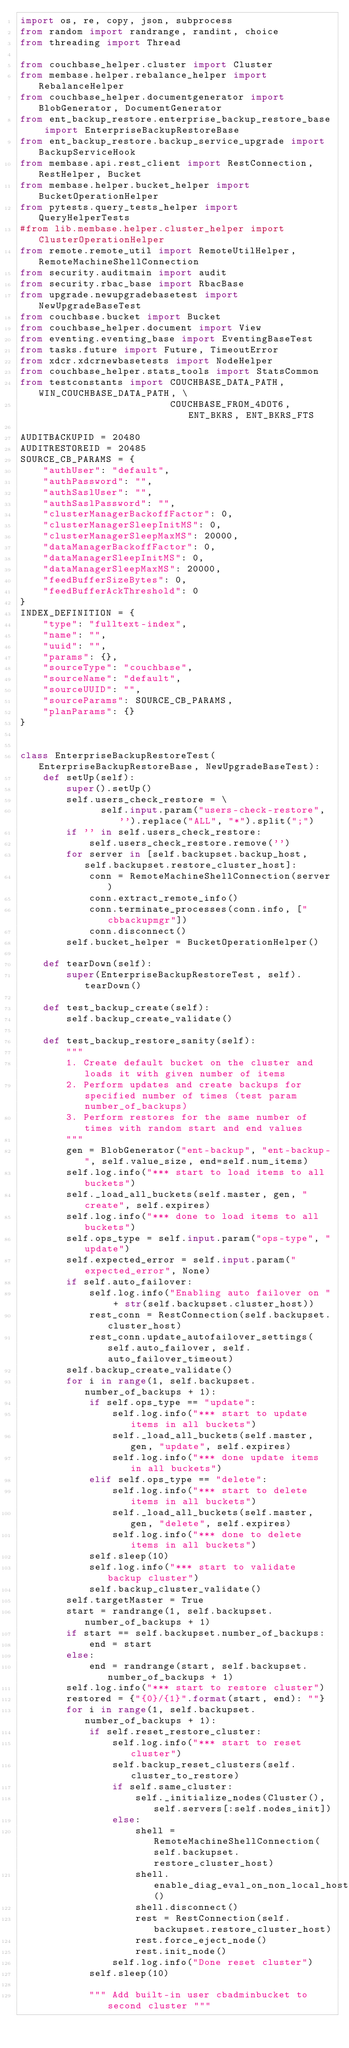Convert code to text. <code><loc_0><loc_0><loc_500><loc_500><_Python_>import os, re, copy, json, subprocess
from random import randrange, randint, choice
from threading import Thread

from couchbase_helper.cluster import Cluster
from membase.helper.rebalance_helper import RebalanceHelper
from couchbase_helper.documentgenerator import BlobGenerator, DocumentGenerator
from ent_backup_restore.enterprise_backup_restore_base import EnterpriseBackupRestoreBase
from ent_backup_restore.backup_service_upgrade import BackupServiceHook
from membase.api.rest_client import RestConnection, RestHelper, Bucket
from membase.helper.bucket_helper import BucketOperationHelper
from pytests.query_tests_helper import QueryHelperTests
#from lib.membase.helper.cluster_helper import ClusterOperationHelper
from remote.remote_util import RemoteUtilHelper, RemoteMachineShellConnection
from security.auditmain import audit
from security.rbac_base import RbacBase
from upgrade.newupgradebasetest import NewUpgradeBaseTest
from couchbase.bucket import Bucket
from couchbase_helper.document import View
from eventing.eventing_base import EventingBaseTest
from tasks.future import Future, TimeoutError
from xdcr.xdcrnewbasetests import NodeHelper
from couchbase_helper.stats_tools import StatsCommon
from testconstants import COUCHBASE_DATA_PATH, WIN_COUCHBASE_DATA_PATH, \
                          COUCHBASE_FROM_4DOT6, ENT_BKRS, ENT_BKRS_FTS

AUDITBACKUPID = 20480
AUDITRESTOREID = 20485
SOURCE_CB_PARAMS = {
    "authUser": "default",
    "authPassword": "",
    "authSaslUser": "",
    "authSaslPassword": "",
    "clusterManagerBackoffFactor": 0,
    "clusterManagerSleepInitMS": 0,
    "clusterManagerSleepMaxMS": 20000,
    "dataManagerBackoffFactor": 0,
    "dataManagerSleepInitMS": 0,
    "dataManagerSleepMaxMS": 20000,
    "feedBufferSizeBytes": 0,
    "feedBufferAckThreshold": 0
}
INDEX_DEFINITION = {
    "type": "fulltext-index",
    "name": "",
    "uuid": "",
    "params": {},
    "sourceType": "couchbase",
    "sourceName": "default",
    "sourceUUID": "",
    "sourceParams": SOURCE_CB_PARAMS,
    "planParams": {}
}


class EnterpriseBackupRestoreTest(EnterpriseBackupRestoreBase, NewUpgradeBaseTest):
    def setUp(self):
        super().setUp()
        self.users_check_restore = \
              self.input.param("users-check-restore", '').replace("ALL", "*").split(";")
        if '' in self.users_check_restore:
            self.users_check_restore.remove('')
        for server in [self.backupset.backup_host, self.backupset.restore_cluster_host]:
            conn = RemoteMachineShellConnection(server)
            conn.extract_remote_info()
            conn.terminate_processes(conn.info, ["cbbackupmgr"])
            conn.disconnect()
        self.bucket_helper = BucketOperationHelper()

    def tearDown(self):
        super(EnterpriseBackupRestoreTest, self).tearDown()

    def test_backup_create(self):
        self.backup_create_validate()

    def test_backup_restore_sanity(self):
        """
        1. Create default bucket on the cluster and loads it with given number of items
        2. Perform updates and create backups for specified number of times (test param number_of_backups)
        3. Perform restores for the same number of times with random start and end values
        """
        gen = BlobGenerator("ent-backup", "ent-backup-", self.value_size, end=self.num_items)
        self.log.info("*** start to load items to all buckets")
        self._load_all_buckets(self.master, gen, "create", self.expires)
        self.log.info("*** done to load items to all buckets")
        self.ops_type = self.input.param("ops-type", "update")
        self.expected_error = self.input.param("expected_error", None)
        if self.auto_failover:
            self.log.info("Enabling auto failover on " + str(self.backupset.cluster_host))
            rest_conn = RestConnection(self.backupset.cluster_host)
            rest_conn.update_autofailover_settings(self.auto_failover, self.auto_failover_timeout)
        self.backup_create_validate()
        for i in range(1, self.backupset.number_of_backups + 1):
            if self.ops_type == "update":
                self.log.info("*** start to update items in all buckets")
                self._load_all_buckets(self.master, gen, "update", self.expires)
                self.log.info("*** done update items in all buckets")
            elif self.ops_type == "delete":
                self.log.info("*** start to delete items in all buckets")
                self._load_all_buckets(self.master, gen, "delete", self.expires)
                self.log.info("*** done to delete items in all buckets")
            self.sleep(10)
            self.log.info("*** start to validate backup cluster")
            self.backup_cluster_validate()
        self.targetMaster = True
        start = randrange(1, self.backupset.number_of_backups + 1)
        if start == self.backupset.number_of_backups:
            end = start
        else:
            end = randrange(start, self.backupset.number_of_backups + 1)
        self.log.info("*** start to restore cluster")
        restored = {"{0}/{1}".format(start, end): ""}
        for i in range(1, self.backupset.number_of_backups + 1):
            if self.reset_restore_cluster:
                self.log.info("*** start to reset cluster")
                self.backup_reset_clusters(self.cluster_to_restore)
                if self.same_cluster:
                    self._initialize_nodes(Cluster(), self.servers[:self.nodes_init])
                else:
                    shell = RemoteMachineShellConnection(self.backupset.restore_cluster_host)
                    shell.enable_diag_eval_on_non_local_hosts()
                    shell.disconnect()
                    rest = RestConnection(self.backupset.restore_cluster_host)
                    rest.force_eject_node()
                    rest.init_node()
                self.log.info("Done reset cluster")
            self.sleep(10)

            """ Add built-in user cbadminbucket to second cluster """</code> 